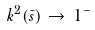Convert formula to latex. <formula><loc_0><loc_0><loc_500><loc_500>k ^ { 2 } ( \bar { s } ) \, \to \, 1 ^ { - } \,</formula> 